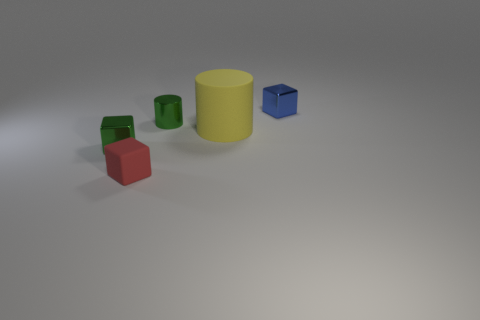Add 4 tiny red matte things. How many objects exist? 9 Subtract all cylinders. How many objects are left? 3 Subtract all small blue shiny cubes. Subtract all red things. How many objects are left? 3 Add 2 tiny blue metallic cubes. How many tiny blue metallic cubes are left? 3 Add 5 red things. How many red things exist? 6 Subtract 0 green spheres. How many objects are left? 5 